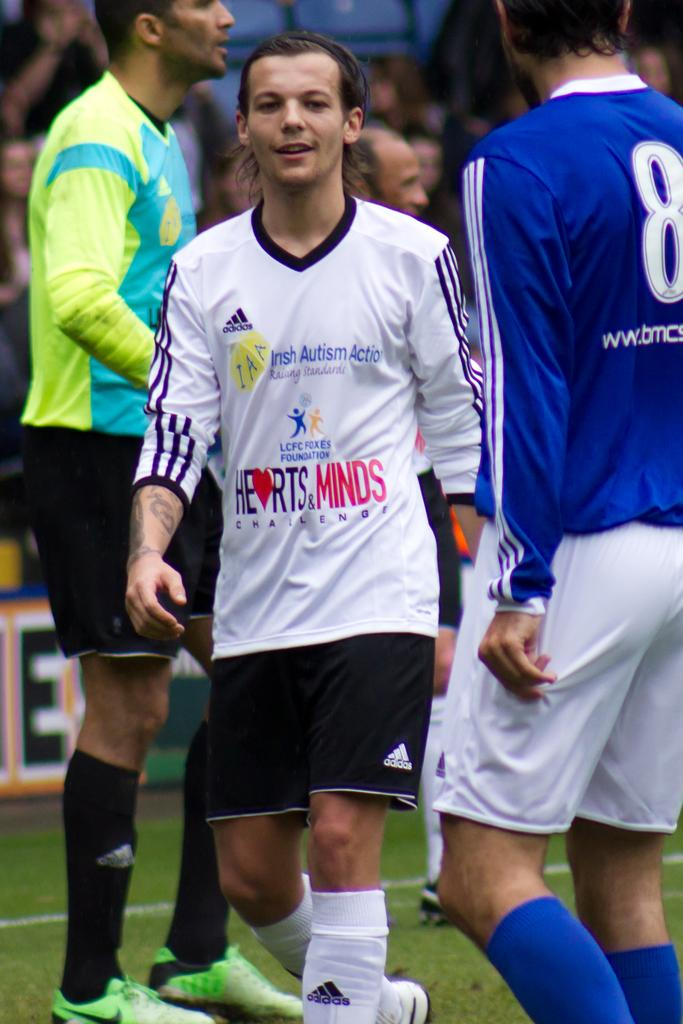<image>
Render a clear and concise summary of the photo. A man is supporting Irish Autism Action by playing soccer with others. 